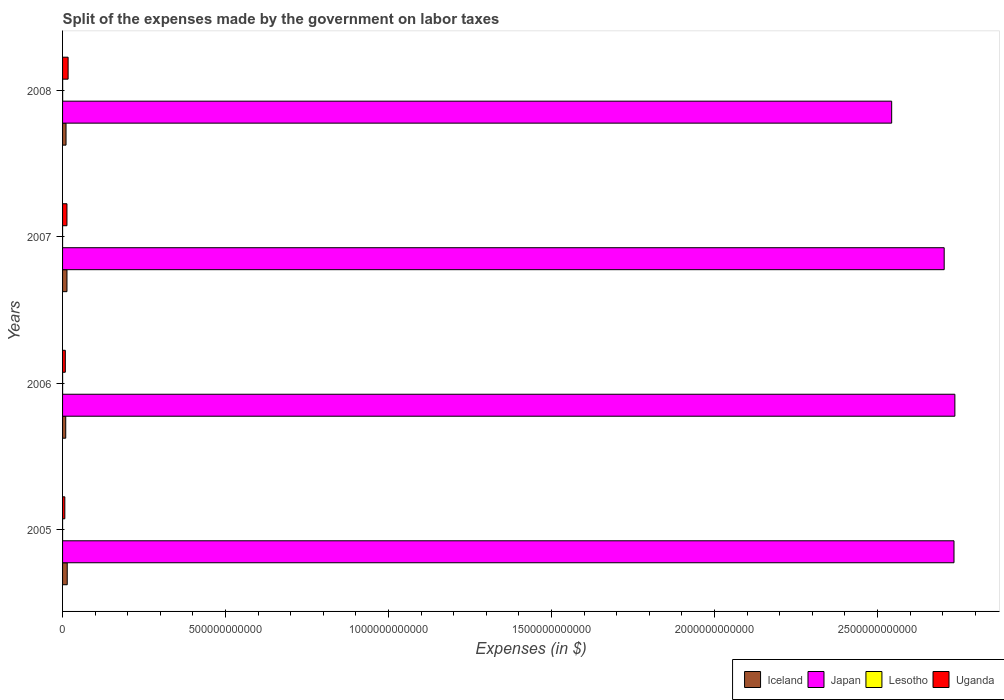How many different coloured bars are there?
Your answer should be very brief. 4. How many groups of bars are there?
Ensure brevity in your answer.  4. What is the label of the 3rd group of bars from the top?
Offer a very short reply. 2006. In how many cases, is the number of bars for a given year not equal to the number of legend labels?
Ensure brevity in your answer.  0. What is the expenses made by the government on labor taxes in Uganda in 2005?
Provide a short and direct response. 6.95e+09. Across all years, what is the maximum expenses made by the government on labor taxes in Iceland?
Ensure brevity in your answer.  1.43e+1. Across all years, what is the minimum expenses made by the government on labor taxes in Lesotho?
Your answer should be very brief. 6.62e+06. In which year was the expenses made by the government on labor taxes in Iceland maximum?
Make the answer very short. 2005. What is the total expenses made by the government on labor taxes in Uganda in the graph?
Your response must be concise. 4.58e+1. What is the difference between the expenses made by the government on labor taxes in Japan in 2006 and that in 2007?
Your answer should be very brief. 3.28e+1. What is the difference between the expenses made by the government on labor taxes in Japan in 2005 and the expenses made by the government on labor taxes in Uganda in 2007?
Offer a terse response. 2.72e+12. What is the average expenses made by the government on labor taxes in Lesotho per year?
Offer a very short reply. 7.84e+07. In the year 2005, what is the difference between the expenses made by the government on labor taxes in Japan and expenses made by the government on labor taxes in Lesotho?
Your response must be concise. 2.73e+12. What is the ratio of the expenses made by the government on labor taxes in Uganda in 2006 to that in 2008?
Your response must be concise. 0.49. Is the expenses made by the government on labor taxes in Iceland in 2005 less than that in 2007?
Your answer should be very brief. No. Is the difference between the expenses made by the government on labor taxes in Japan in 2005 and 2008 greater than the difference between the expenses made by the government on labor taxes in Lesotho in 2005 and 2008?
Your answer should be compact. Yes. What is the difference between the highest and the second highest expenses made by the government on labor taxes in Lesotho?
Your answer should be compact. 1.51e+08. What is the difference between the highest and the lowest expenses made by the government on labor taxes in Lesotho?
Give a very brief answer. 2.19e+08. Is the sum of the expenses made by the government on labor taxes in Iceland in 2005 and 2007 greater than the maximum expenses made by the government on labor taxes in Japan across all years?
Provide a short and direct response. No. What does the 3rd bar from the top in 2008 represents?
Your response must be concise. Japan. What does the 4th bar from the bottom in 2007 represents?
Ensure brevity in your answer.  Uganda. What is the difference between two consecutive major ticks on the X-axis?
Ensure brevity in your answer.  5.00e+11. Are the values on the major ticks of X-axis written in scientific E-notation?
Make the answer very short. No. Does the graph contain any zero values?
Offer a very short reply. No. Does the graph contain grids?
Make the answer very short. No. What is the title of the graph?
Provide a succinct answer. Split of the expenses made by the government on labor taxes. Does "Namibia" appear as one of the legend labels in the graph?
Give a very brief answer. No. What is the label or title of the X-axis?
Make the answer very short. Expenses (in $). What is the Expenses (in $) of Iceland in 2005?
Provide a succinct answer. 1.43e+1. What is the Expenses (in $) in Japan in 2005?
Offer a terse response. 2.73e+12. What is the Expenses (in $) in Lesotho in 2005?
Make the answer very short. 6.74e+06. What is the Expenses (in $) of Uganda in 2005?
Provide a short and direct response. 6.95e+09. What is the Expenses (in $) of Iceland in 2006?
Give a very brief answer. 9.70e+09. What is the Expenses (in $) in Japan in 2006?
Offer a terse response. 2.74e+12. What is the Expenses (in $) in Lesotho in 2006?
Offer a terse response. 7.48e+07. What is the Expenses (in $) of Uganda in 2006?
Your response must be concise. 8.41e+09. What is the Expenses (in $) in Iceland in 2007?
Make the answer very short. 1.35e+1. What is the Expenses (in $) of Japan in 2007?
Make the answer very short. 2.70e+12. What is the Expenses (in $) of Lesotho in 2007?
Give a very brief answer. 6.62e+06. What is the Expenses (in $) in Uganda in 2007?
Offer a terse response. 1.35e+1. What is the Expenses (in $) in Iceland in 2008?
Provide a short and direct response. 1.06e+1. What is the Expenses (in $) of Japan in 2008?
Your response must be concise. 2.54e+12. What is the Expenses (in $) in Lesotho in 2008?
Ensure brevity in your answer.  2.26e+08. What is the Expenses (in $) in Uganda in 2008?
Offer a terse response. 1.70e+1. Across all years, what is the maximum Expenses (in $) of Iceland?
Your answer should be very brief. 1.43e+1. Across all years, what is the maximum Expenses (in $) of Japan?
Give a very brief answer. 2.74e+12. Across all years, what is the maximum Expenses (in $) of Lesotho?
Provide a short and direct response. 2.26e+08. Across all years, what is the maximum Expenses (in $) of Uganda?
Ensure brevity in your answer.  1.70e+1. Across all years, what is the minimum Expenses (in $) in Iceland?
Your answer should be very brief. 9.70e+09. Across all years, what is the minimum Expenses (in $) in Japan?
Your answer should be compact. 2.54e+12. Across all years, what is the minimum Expenses (in $) of Lesotho?
Keep it short and to the point. 6.62e+06. Across all years, what is the minimum Expenses (in $) in Uganda?
Keep it short and to the point. 6.95e+09. What is the total Expenses (in $) of Iceland in the graph?
Ensure brevity in your answer.  4.82e+1. What is the total Expenses (in $) of Japan in the graph?
Ensure brevity in your answer.  1.07e+13. What is the total Expenses (in $) of Lesotho in the graph?
Provide a succinct answer. 3.14e+08. What is the total Expenses (in $) of Uganda in the graph?
Your response must be concise. 4.58e+1. What is the difference between the Expenses (in $) of Iceland in 2005 and that in 2006?
Ensure brevity in your answer.  4.60e+09. What is the difference between the Expenses (in $) in Japan in 2005 and that in 2006?
Make the answer very short. -2.70e+09. What is the difference between the Expenses (in $) in Lesotho in 2005 and that in 2006?
Your answer should be very brief. -6.81e+07. What is the difference between the Expenses (in $) of Uganda in 2005 and that in 2006?
Your answer should be very brief. -1.47e+09. What is the difference between the Expenses (in $) of Iceland in 2005 and that in 2007?
Provide a short and direct response. 7.77e+08. What is the difference between the Expenses (in $) in Japan in 2005 and that in 2007?
Offer a very short reply. 3.01e+1. What is the difference between the Expenses (in $) in Lesotho in 2005 and that in 2007?
Provide a succinct answer. 1.16e+05. What is the difference between the Expenses (in $) in Uganda in 2005 and that in 2007?
Offer a terse response. -6.53e+09. What is the difference between the Expenses (in $) in Iceland in 2005 and that in 2008?
Ensure brevity in your answer.  3.65e+09. What is the difference between the Expenses (in $) in Japan in 2005 and that in 2008?
Your answer should be compact. 1.91e+11. What is the difference between the Expenses (in $) of Lesotho in 2005 and that in 2008?
Keep it short and to the point. -2.19e+08. What is the difference between the Expenses (in $) of Uganda in 2005 and that in 2008?
Your answer should be very brief. -1.01e+1. What is the difference between the Expenses (in $) of Iceland in 2006 and that in 2007?
Your answer should be very brief. -3.82e+09. What is the difference between the Expenses (in $) in Japan in 2006 and that in 2007?
Give a very brief answer. 3.28e+1. What is the difference between the Expenses (in $) of Lesotho in 2006 and that in 2007?
Your answer should be compact. 6.82e+07. What is the difference between the Expenses (in $) in Uganda in 2006 and that in 2007?
Your response must be concise. -5.06e+09. What is the difference between the Expenses (in $) in Iceland in 2006 and that in 2008?
Ensure brevity in your answer.  -9.48e+08. What is the difference between the Expenses (in $) in Japan in 2006 and that in 2008?
Give a very brief answer. 1.94e+11. What is the difference between the Expenses (in $) in Lesotho in 2006 and that in 2008?
Your answer should be very brief. -1.51e+08. What is the difference between the Expenses (in $) in Uganda in 2006 and that in 2008?
Give a very brief answer. -8.60e+09. What is the difference between the Expenses (in $) of Iceland in 2007 and that in 2008?
Provide a succinct answer. 2.87e+09. What is the difference between the Expenses (in $) in Japan in 2007 and that in 2008?
Your answer should be compact. 1.61e+11. What is the difference between the Expenses (in $) of Lesotho in 2007 and that in 2008?
Give a very brief answer. -2.19e+08. What is the difference between the Expenses (in $) in Uganda in 2007 and that in 2008?
Provide a succinct answer. -3.54e+09. What is the difference between the Expenses (in $) in Iceland in 2005 and the Expenses (in $) in Japan in 2006?
Make the answer very short. -2.72e+12. What is the difference between the Expenses (in $) in Iceland in 2005 and the Expenses (in $) in Lesotho in 2006?
Provide a succinct answer. 1.42e+1. What is the difference between the Expenses (in $) in Iceland in 2005 and the Expenses (in $) in Uganda in 2006?
Ensure brevity in your answer.  5.89e+09. What is the difference between the Expenses (in $) of Japan in 2005 and the Expenses (in $) of Lesotho in 2006?
Offer a terse response. 2.73e+12. What is the difference between the Expenses (in $) in Japan in 2005 and the Expenses (in $) in Uganda in 2006?
Keep it short and to the point. 2.73e+12. What is the difference between the Expenses (in $) in Lesotho in 2005 and the Expenses (in $) in Uganda in 2006?
Offer a very short reply. -8.41e+09. What is the difference between the Expenses (in $) of Iceland in 2005 and the Expenses (in $) of Japan in 2007?
Your response must be concise. -2.69e+12. What is the difference between the Expenses (in $) in Iceland in 2005 and the Expenses (in $) in Lesotho in 2007?
Provide a succinct answer. 1.43e+1. What is the difference between the Expenses (in $) in Iceland in 2005 and the Expenses (in $) in Uganda in 2007?
Offer a very short reply. 8.27e+08. What is the difference between the Expenses (in $) in Japan in 2005 and the Expenses (in $) in Lesotho in 2007?
Provide a short and direct response. 2.73e+12. What is the difference between the Expenses (in $) in Japan in 2005 and the Expenses (in $) in Uganda in 2007?
Your answer should be very brief. 2.72e+12. What is the difference between the Expenses (in $) in Lesotho in 2005 and the Expenses (in $) in Uganda in 2007?
Make the answer very short. -1.35e+1. What is the difference between the Expenses (in $) of Iceland in 2005 and the Expenses (in $) of Japan in 2008?
Ensure brevity in your answer.  -2.53e+12. What is the difference between the Expenses (in $) in Iceland in 2005 and the Expenses (in $) in Lesotho in 2008?
Give a very brief answer. 1.41e+1. What is the difference between the Expenses (in $) in Iceland in 2005 and the Expenses (in $) in Uganda in 2008?
Provide a succinct answer. -2.71e+09. What is the difference between the Expenses (in $) of Japan in 2005 and the Expenses (in $) of Lesotho in 2008?
Your answer should be very brief. 2.73e+12. What is the difference between the Expenses (in $) of Japan in 2005 and the Expenses (in $) of Uganda in 2008?
Provide a short and direct response. 2.72e+12. What is the difference between the Expenses (in $) in Lesotho in 2005 and the Expenses (in $) in Uganda in 2008?
Offer a terse response. -1.70e+1. What is the difference between the Expenses (in $) of Iceland in 2006 and the Expenses (in $) of Japan in 2007?
Ensure brevity in your answer.  -2.69e+12. What is the difference between the Expenses (in $) in Iceland in 2006 and the Expenses (in $) in Lesotho in 2007?
Give a very brief answer. 9.70e+09. What is the difference between the Expenses (in $) in Iceland in 2006 and the Expenses (in $) in Uganda in 2007?
Provide a short and direct response. -3.77e+09. What is the difference between the Expenses (in $) of Japan in 2006 and the Expenses (in $) of Lesotho in 2007?
Provide a succinct answer. 2.74e+12. What is the difference between the Expenses (in $) in Japan in 2006 and the Expenses (in $) in Uganda in 2007?
Ensure brevity in your answer.  2.72e+12. What is the difference between the Expenses (in $) in Lesotho in 2006 and the Expenses (in $) in Uganda in 2007?
Provide a short and direct response. -1.34e+1. What is the difference between the Expenses (in $) of Iceland in 2006 and the Expenses (in $) of Japan in 2008?
Keep it short and to the point. -2.53e+12. What is the difference between the Expenses (in $) of Iceland in 2006 and the Expenses (in $) of Lesotho in 2008?
Make the answer very short. 9.48e+09. What is the difference between the Expenses (in $) in Iceland in 2006 and the Expenses (in $) in Uganda in 2008?
Give a very brief answer. -7.31e+09. What is the difference between the Expenses (in $) in Japan in 2006 and the Expenses (in $) in Lesotho in 2008?
Give a very brief answer. 2.74e+12. What is the difference between the Expenses (in $) in Japan in 2006 and the Expenses (in $) in Uganda in 2008?
Your answer should be very brief. 2.72e+12. What is the difference between the Expenses (in $) in Lesotho in 2006 and the Expenses (in $) in Uganda in 2008?
Provide a short and direct response. -1.69e+1. What is the difference between the Expenses (in $) of Iceland in 2007 and the Expenses (in $) of Japan in 2008?
Your response must be concise. -2.53e+12. What is the difference between the Expenses (in $) of Iceland in 2007 and the Expenses (in $) of Lesotho in 2008?
Your answer should be very brief. 1.33e+1. What is the difference between the Expenses (in $) in Iceland in 2007 and the Expenses (in $) in Uganda in 2008?
Offer a very short reply. -3.48e+09. What is the difference between the Expenses (in $) of Japan in 2007 and the Expenses (in $) of Lesotho in 2008?
Keep it short and to the point. 2.70e+12. What is the difference between the Expenses (in $) of Japan in 2007 and the Expenses (in $) of Uganda in 2008?
Offer a very short reply. 2.69e+12. What is the difference between the Expenses (in $) in Lesotho in 2007 and the Expenses (in $) in Uganda in 2008?
Give a very brief answer. -1.70e+1. What is the average Expenses (in $) in Iceland per year?
Offer a terse response. 1.20e+1. What is the average Expenses (in $) of Japan per year?
Make the answer very short. 2.68e+12. What is the average Expenses (in $) in Lesotho per year?
Make the answer very short. 7.84e+07. What is the average Expenses (in $) of Uganda per year?
Offer a terse response. 1.15e+1. In the year 2005, what is the difference between the Expenses (in $) in Iceland and Expenses (in $) in Japan?
Provide a succinct answer. -2.72e+12. In the year 2005, what is the difference between the Expenses (in $) of Iceland and Expenses (in $) of Lesotho?
Offer a very short reply. 1.43e+1. In the year 2005, what is the difference between the Expenses (in $) in Iceland and Expenses (in $) in Uganda?
Offer a terse response. 7.35e+09. In the year 2005, what is the difference between the Expenses (in $) in Japan and Expenses (in $) in Lesotho?
Your answer should be very brief. 2.73e+12. In the year 2005, what is the difference between the Expenses (in $) of Japan and Expenses (in $) of Uganda?
Keep it short and to the point. 2.73e+12. In the year 2005, what is the difference between the Expenses (in $) of Lesotho and Expenses (in $) of Uganda?
Make the answer very short. -6.94e+09. In the year 2006, what is the difference between the Expenses (in $) of Iceland and Expenses (in $) of Japan?
Keep it short and to the point. -2.73e+12. In the year 2006, what is the difference between the Expenses (in $) of Iceland and Expenses (in $) of Lesotho?
Offer a terse response. 9.63e+09. In the year 2006, what is the difference between the Expenses (in $) in Iceland and Expenses (in $) in Uganda?
Provide a succinct answer. 1.29e+09. In the year 2006, what is the difference between the Expenses (in $) in Japan and Expenses (in $) in Lesotho?
Offer a terse response. 2.74e+12. In the year 2006, what is the difference between the Expenses (in $) in Japan and Expenses (in $) in Uganda?
Offer a terse response. 2.73e+12. In the year 2006, what is the difference between the Expenses (in $) of Lesotho and Expenses (in $) of Uganda?
Provide a succinct answer. -8.34e+09. In the year 2007, what is the difference between the Expenses (in $) in Iceland and Expenses (in $) in Japan?
Your response must be concise. -2.69e+12. In the year 2007, what is the difference between the Expenses (in $) in Iceland and Expenses (in $) in Lesotho?
Your response must be concise. 1.35e+1. In the year 2007, what is the difference between the Expenses (in $) in Iceland and Expenses (in $) in Uganda?
Your response must be concise. 5.02e+07. In the year 2007, what is the difference between the Expenses (in $) in Japan and Expenses (in $) in Lesotho?
Offer a terse response. 2.70e+12. In the year 2007, what is the difference between the Expenses (in $) in Japan and Expenses (in $) in Uganda?
Give a very brief answer. 2.69e+12. In the year 2007, what is the difference between the Expenses (in $) of Lesotho and Expenses (in $) of Uganda?
Provide a short and direct response. -1.35e+1. In the year 2008, what is the difference between the Expenses (in $) of Iceland and Expenses (in $) of Japan?
Your answer should be very brief. -2.53e+12. In the year 2008, what is the difference between the Expenses (in $) in Iceland and Expenses (in $) in Lesotho?
Provide a short and direct response. 1.04e+1. In the year 2008, what is the difference between the Expenses (in $) in Iceland and Expenses (in $) in Uganda?
Your answer should be compact. -6.36e+09. In the year 2008, what is the difference between the Expenses (in $) of Japan and Expenses (in $) of Lesotho?
Keep it short and to the point. 2.54e+12. In the year 2008, what is the difference between the Expenses (in $) of Japan and Expenses (in $) of Uganda?
Offer a very short reply. 2.53e+12. In the year 2008, what is the difference between the Expenses (in $) in Lesotho and Expenses (in $) in Uganda?
Provide a short and direct response. -1.68e+1. What is the ratio of the Expenses (in $) of Iceland in 2005 to that in 2006?
Your answer should be compact. 1.47. What is the ratio of the Expenses (in $) of Lesotho in 2005 to that in 2006?
Provide a succinct answer. 0.09. What is the ratio of the Expenses (in $) in Uganda in 2005 to that in 2006?
Keep it short and to the point. 0.83. What is the ratio of the Expenses (in $) of Iceland in 2005 to that in 2007?
Offer a terse response. 1.06. What is the ratio of the Expenses (in $) of Japan in 2005 to that in 2007?
Your answer should be very brief. 1.01. What is the ratio of the Expenses (in $) of Lesotho in 2005 to that in 2007?
Your answer should be very brief. 1.02. What is the ratio of the Expenses (in $) in Uganda in 2005 to that in 2007?
Keep it short and to the point. 0.52. What is the ratio of the Expenses (in $) of Iceland in 2005 to that in 2008?
Give a very brief answer. 1.34. What is the ratio of the Expenses (in $) in Japan in 2005 to that in 2008?
Make the answer very short. 1.08. What is the ratio of the Expenses (in $) of Lesotho in 2005 to that in 2008?
Ensure brevity in your answer.  0.03. What is the ratio of the Expenses (in $) of Uganda in 2005 to that in 2008?
Ensure brevity in your answer.  0.41. What is the ratio of the Expenses (in $) in Iceland in 2006 to that in 2007?
Make the answer very short. 0.72. What is the ratio of the Expenses (in $) in Japan in 2006 to that in 2007?
Your response must be concise. 1.01. What is the ratio of the Expenses (in $) of Lesotho in 2006 to that in 2007?
Provide a short and direct response. 11.3. What is the ratio of the Expenses (in $) of Uganda in 2006 to that in 2007?
Provide a short and direct response. 0.62. What is the ratio of the Expenses (in $) in Iceland in 2006 to that in 2008?
Your answer should be very brief. 0.91. What is the ratio of the Expenses (in $) in Japan in 2006 to that in 2008?
Offer a terse response. 1.08. What is the ratio of the Expenses (in $) of Lesotho in 2006 to that in 2008?
Your answer should be compact. 0.33. What is the ratio of the Expenses (in $) of Uganda in 2006 to that in 2008?
Your answer should be compact. 0.49. What is the ratio of the Expenses (in $) of Iceland in 2007 to that in 2008?
Make the answer very short. 1.27. What is the ratio of the Expenses (in $) of Japan in 2007 to that in 2008?
Give a very brief answer. 1.06. What is the ratio of the Expenses (in $) in Lesotho in 2007 to that in 2008?
Provide a succinct answer. 0.03. What is the ratio of the Expenses (in $) of Uganda in 2007 to that in 2008?
Offer a terse response. 0.79. What is the difference between the highest and the second highest Expenses (in $) of Iceland?
Your response must be concise. 7.77e+08. What is the difference between the highest and the second highest Expenses (in $) in Japan?
Keep it short and to the point. 2.70e+09. What is the difference between the highest and the second highest Expenses (in $) of Lesotho?
Ensure brevity in your answer.  1.51e+08. What is the difference between the highest and the second highest Expenses (in $) of Uganda?
Your answer should be very brief. 3.54e+09. What is the difference between the highest and the lowest Expenses (in $) in Iceland?
Give a very brief answer. 4.60e+09. What is the difference between the highest and the lowest Expenses (in $) of Japan?
Your answer should be compact. 1.94e+11. What is the difference between the highest and the lowest Expenses (in $) in Lesotho?
Ensure brevity in your answer.  2.19e+08. What is the difference between the highest and the lowest Expenses (in $) in Uganda?
Your response must be concise. 1.01e+1. 